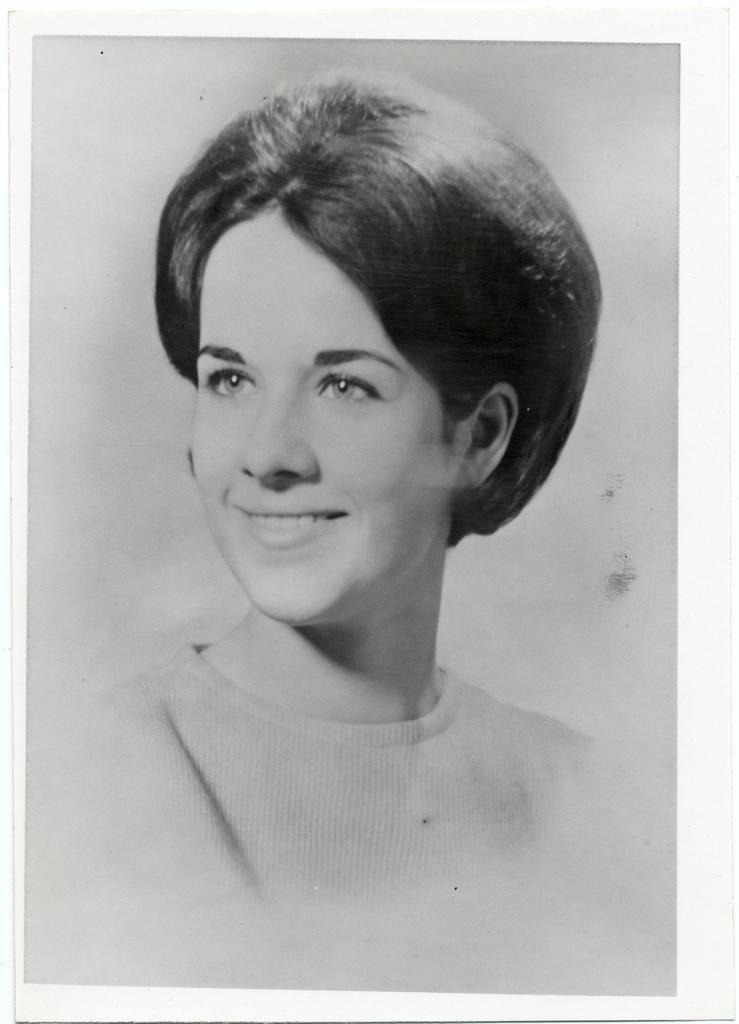What type of image is present in the picture? The image contains a black and white photograph. Who is in the photograph? There is a woman in the photograph. What is the woman doing in the photograph? The woman is smiling. What type of pet can be seen biting the woman in the photograph? There is no pet present in the photograph, nor is there any indication of a bite. 